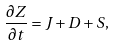<formula> <loc_0><loc_0><loc_500><loc_500>\frac { \partial Z } { \partial t } = J + D + S ,</formula> 